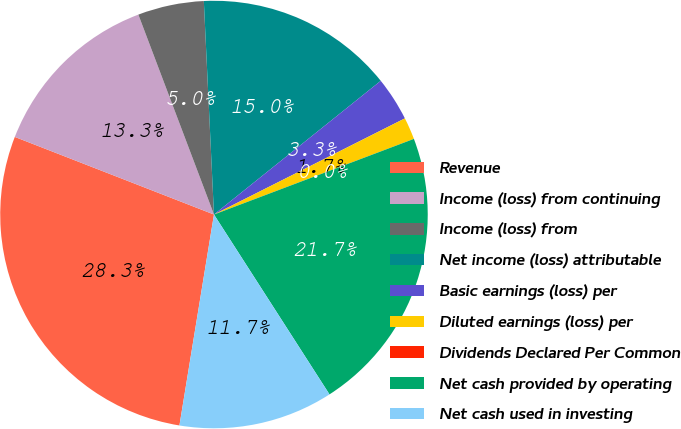Convert chart. <chart><loc_0><loc_0><loc_500><loc_500><pie_chart><fcel>Revenue<fcel>Income (loss) from continuing<fcel>Income (loss) from<fcel>Net income (loss) attributable<fcel>Basic earnings (loss) per<fcel>Diluted earnings (loss) per<fcel>Dividends Declared Per Common<fcel>Net cash provided by operating<fcel>Net cash used in investing<nl><fcel>28.33%<fcel>13.33%<fcel>5.0%<fcel>15.0%<fcel>3.33%<fcel>1.67%<fcel>0.0%<fcel>21.67%<fcel>11.67%<nl></chart> 